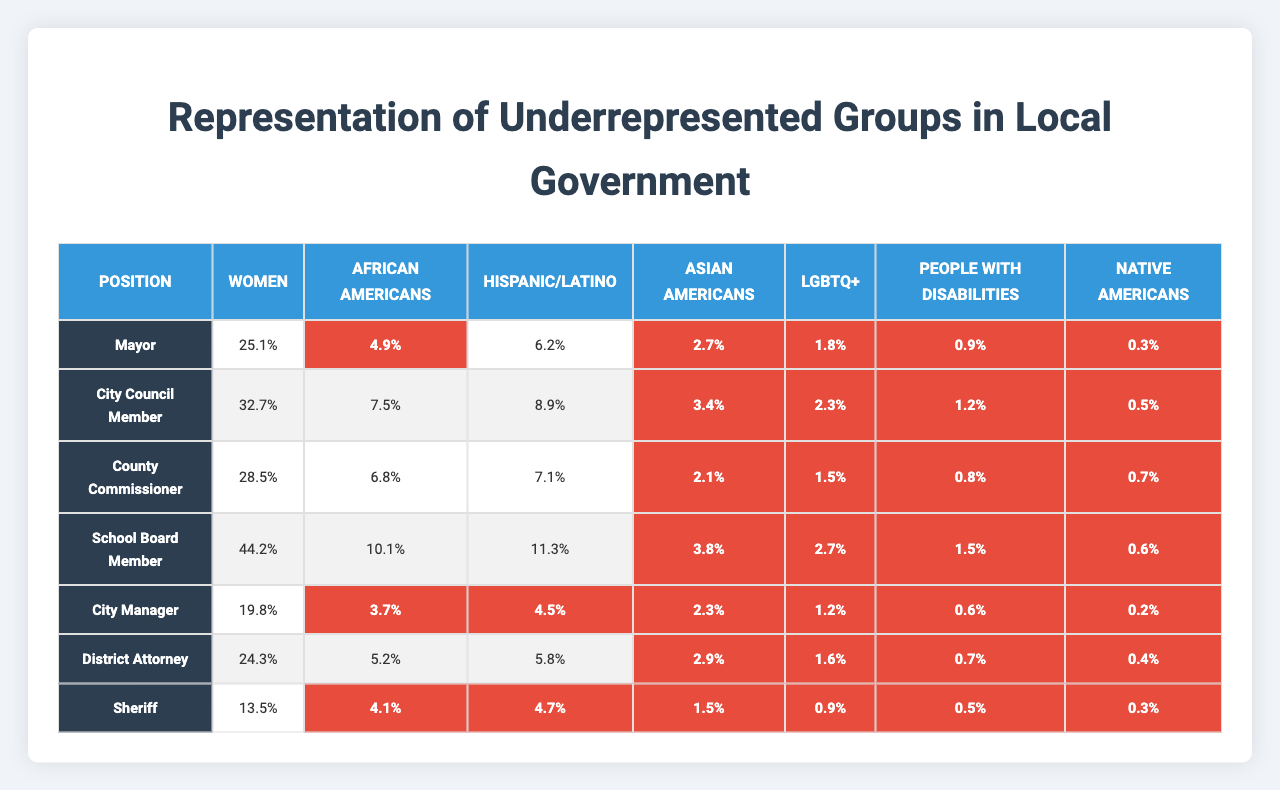What is the representation percentage of women in the School Board Member position? The table shows that the representation percentage of women in the School Board Member position is 44.2%.
Answer: 44.2% Which position has the highest representation percentage for African Americans? The table indicates that the position with the highest representation percentage for African Americans is the School Board Member at 10.1%.
Answer: 10.1% What is the difference in representation percentages of Hispanic/Latino between the Mayor and the City Manager positions? The representation percentage for Hispanic/Latino in the Mayor position is 6.2% and in the City Manager position is 4.5%. The difference is 6.2% - 4.5% = 1.7%.
Answer: 1.7% Is the representation percentage of LGBTQ+ individuals higher in the City Council Member position than in the Sheriff position? The representation percentage for LGBTQ+ in the City Council Member position is 2.3% and in the Sheriff position is 0.9%. Therefore, it is true that the City Council Member position has a higher percentage.
Answer: Yes What is the average representation percentage of People with Disabilities across all positions listed? The representation percentages for People with Disabilities in each position are: 0.9%, 1.2%, 0.8%, 1.5%, 0.6%, 0.7%, and 0.5%. Adding these gives a total of 5.2%, and dividing by 7 (the number of positions) results in an average of 5.2% / 7 = approximately 0.743%.
Answer: 0.743% Which underrepresented group has the lowest representation percentage across all positions? The lowest representation percentages in the table are seen for Native Americans, with a maximum of 0.7% in the County Commissioner position and a minimum of 0.2% in the City Manager position.
Answer: Native Americans What percentage of City Managers are women, and how does it compare to the percentage of women in the Sheriff position? The percentage of City Managers who are women is 19.8%, while the percentage for women in the Sheriff position is 13.5%. The comparison shows that City Managers have a higher percentage of women than Sheriffs.
Answer: Yes How many positions have a representation percentage of less than 5% for Asian Americans? In the table, the representation percentages for Asian Americans are 2.7%, 3.4%, 2.1%, 3.8%, 2.3%, 2.9%, and 1.5%. Out of 7 positions, 5 show a percentage less than 5%.
Answer: 5 